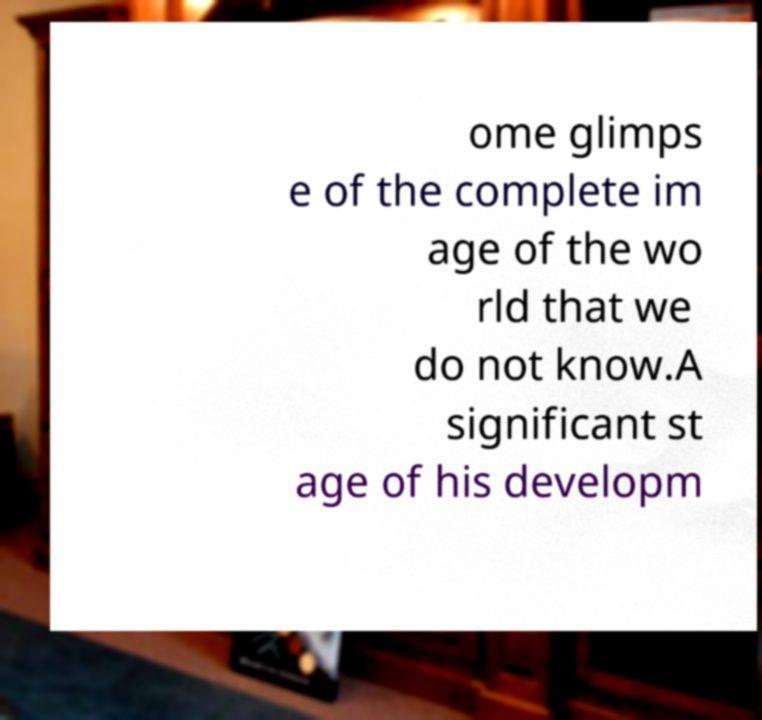Could you assist in decoding the text presented in this image and type it out clearly? ome glimps e of the complete im age of the wo rld that we do not know.A significant st age of his developm 